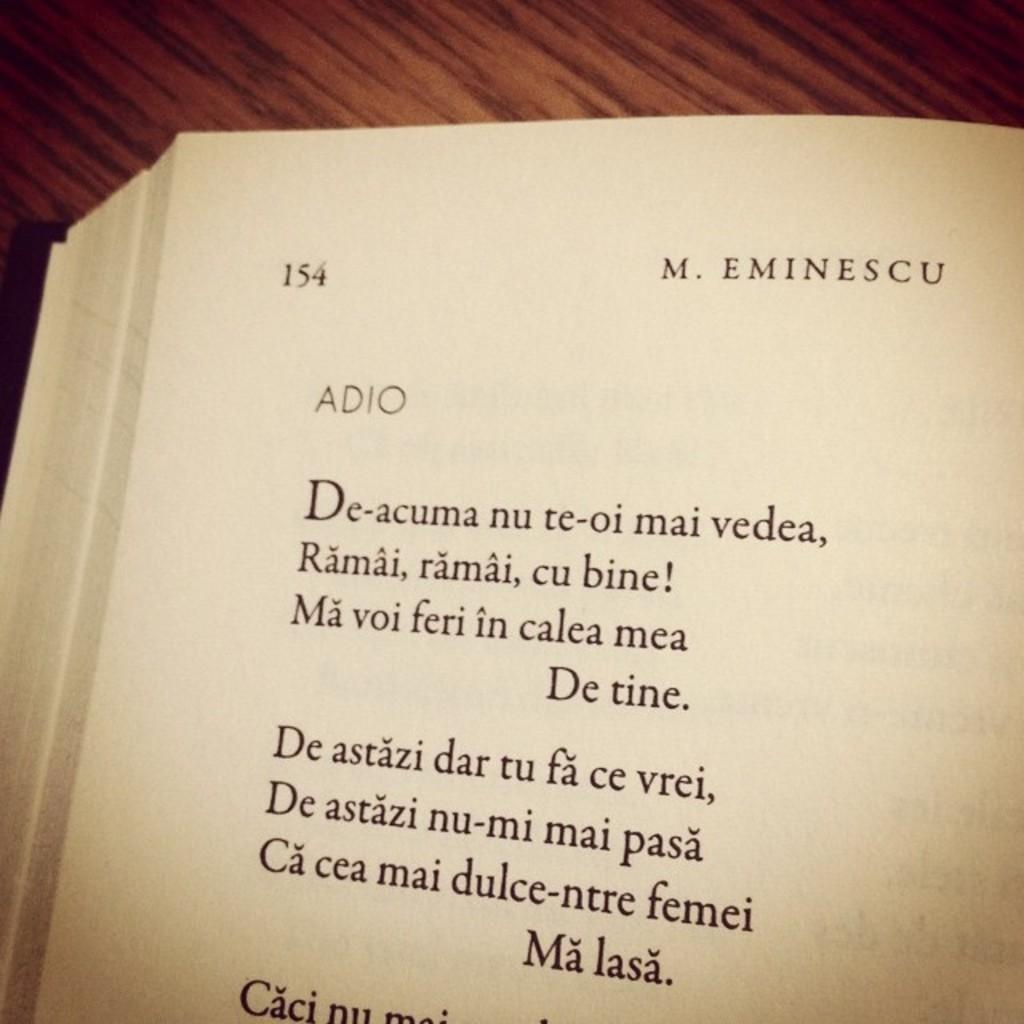Provide a one-sentence caption for the provided image. Page 154 from a book by M. Eminescu contains the poem Adio. 